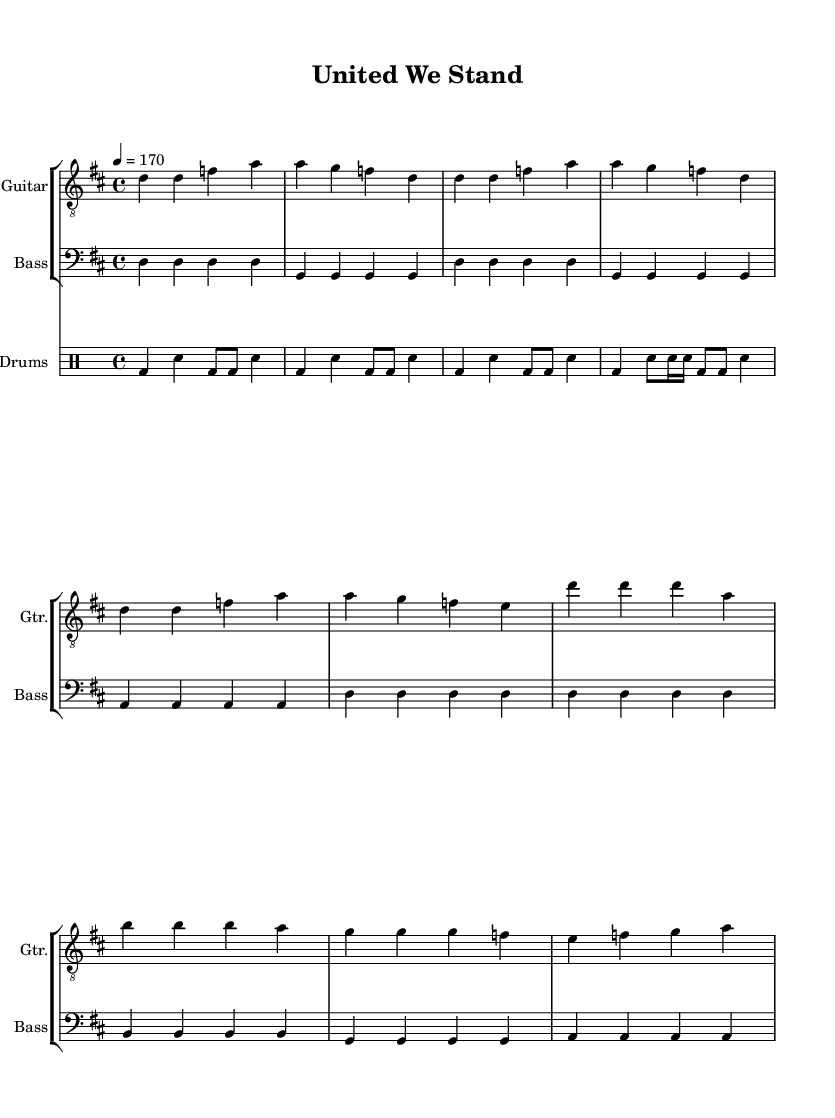What is the key signature of this music? The key signature is D major, which contains two sharps: F# and C#. This information can be found in the initial section of the score, indicated by the key signature at the beginning.
Answer: D major What is the time signature of this music? The time signature is 4/4, meaning there are four beats in each measure and the quarter note receives one beat. It is specified at the start of the score.
Answer: 4/4 What is the tempo marking of this music? The tempo marking is quarter note equals 170 beats per minute. This can be found in the tempo indication at the start of the piece, showing how fast the piece is to be played.
Answer: 170 What are the primary instruments featured in this score? The primary instruments featured are guitar, bass, and drums. This is indicated by the separate staves dedicated to each instrument in the score.
Answer: Guitar, Bass, Drums How many measures are in the chorus? The chorus consists of four measures. By counting the measures in the music section designated for the chorus within the score, we can confirm this.
Answer: 4 What musical genre does this piece belong to? This piece belongs to the punk genre, characterized by its fast tempo, simple musical structures, and themes of unity and diversity, as represented in the lyrics and the overall style.
Answer: Punk 